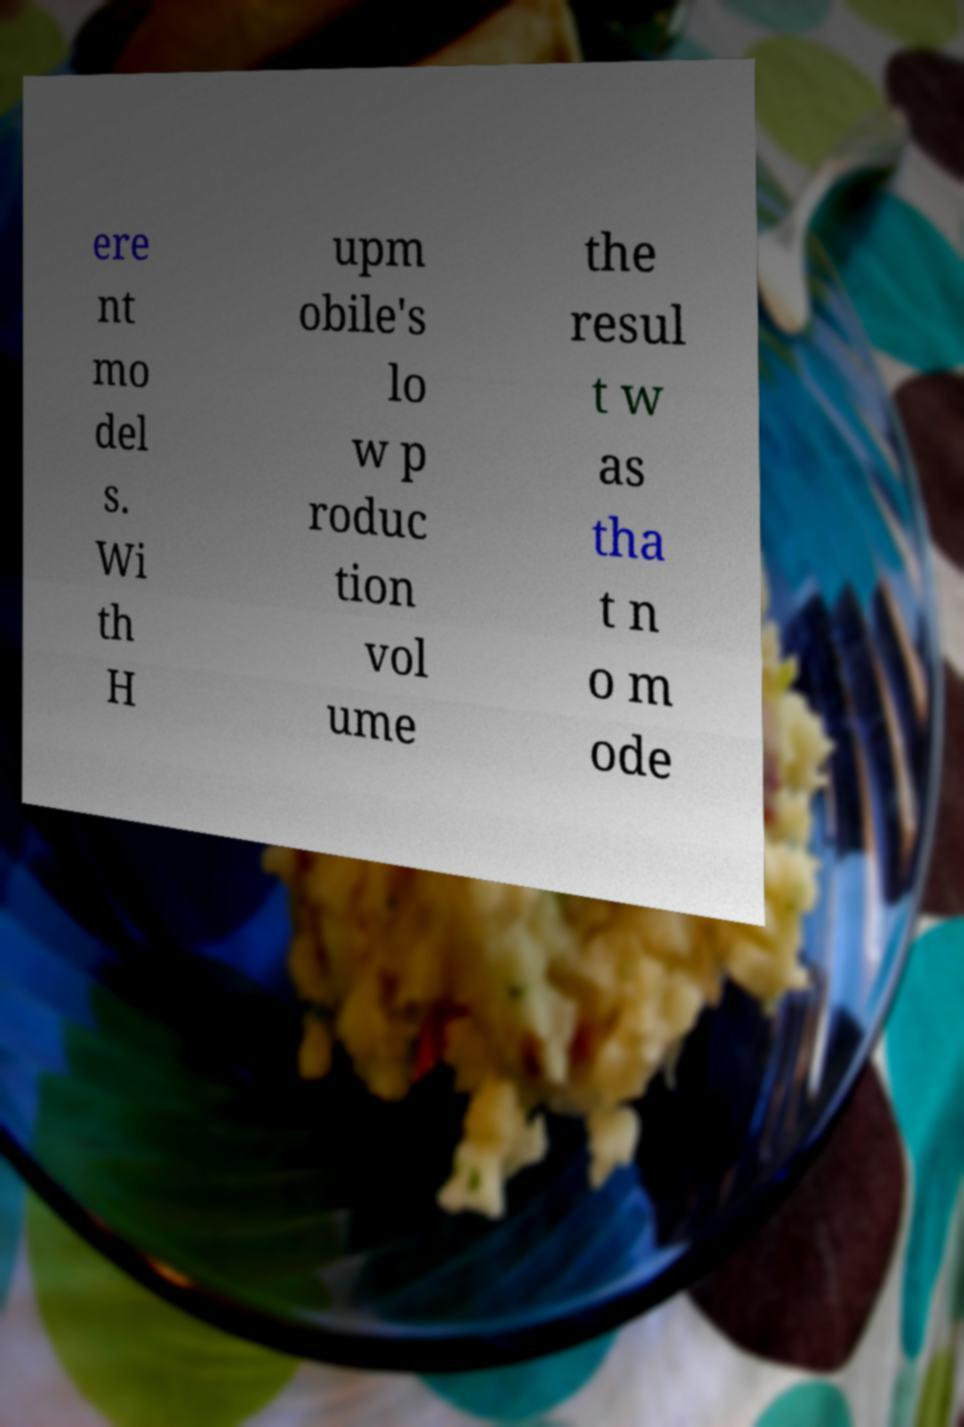I need the written content from this picture converted into text. Can you do that? ere nt mo del s. Wi th H upm obile's lo w p roduc tion vol ume the resul t w as tha t n o m ode 